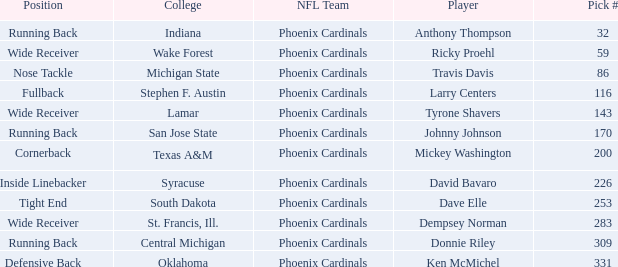Which NFL team has a pick# less than 200 for Travis Davis? Phoenix Cardinals. 